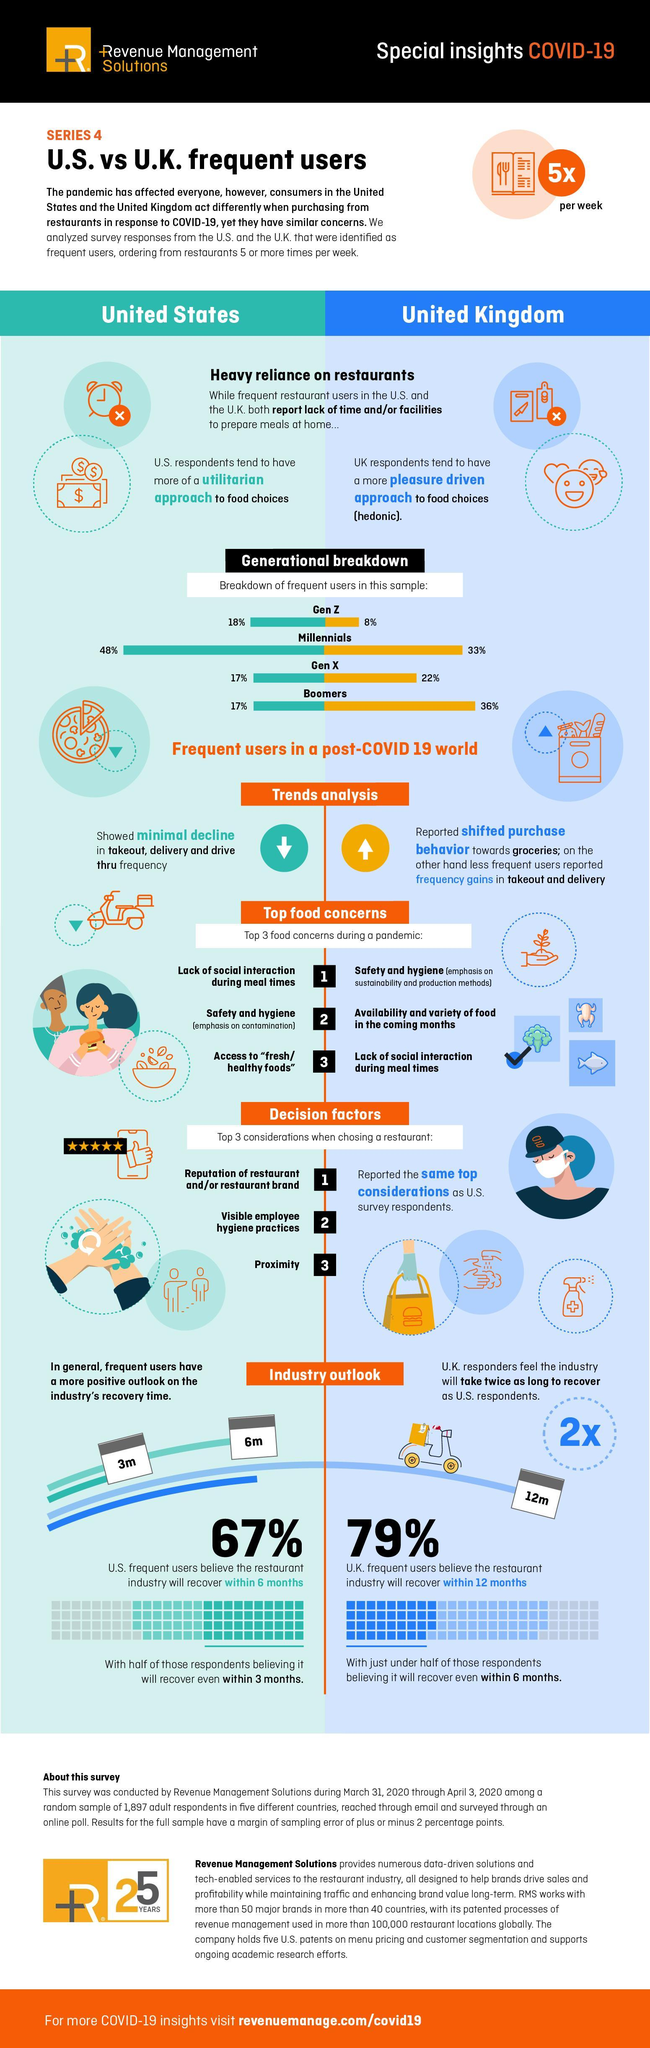What type of approach did US respondents have to food choices?
Answer the question with a short phrase. utilitarian Which respondents showed minimal decline in food buying trends? US 48% of the US respondents were of which generation? Millennials What percent of the UK respondents were from Gen Z? 8% Safety and hygiene was the topmost food concern for which group of respondents? UK 36% of UK respondents were of which generation group? Boomers What was the third major food concern among US respondents? Access to "fresh/ healthy foods" How was the UK respondents approach to food choices? pleasure driven Which respondents reported increase in takeout and delivery? UK How many of the UK responders feel that industry will bounce back in a year? 79% 